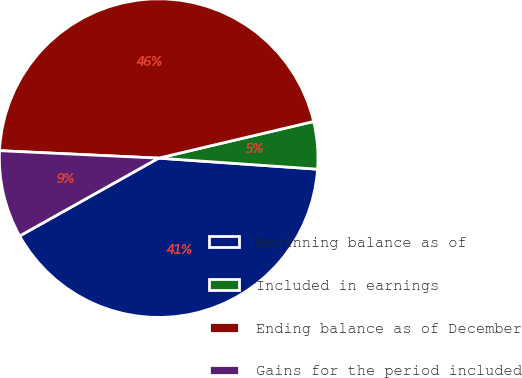<chart> <loc_0><loc_0><loc_500><loc_500><pie_chart><fcel>Beginning balance as of<fcel>Included in earnings<fcel>Ending balance as of December<fcel>Gains for the period included<nl><fcel>40.77%<fcel>4.8%<fcel>45.56%<fcel>8.87%<nl></chart> 